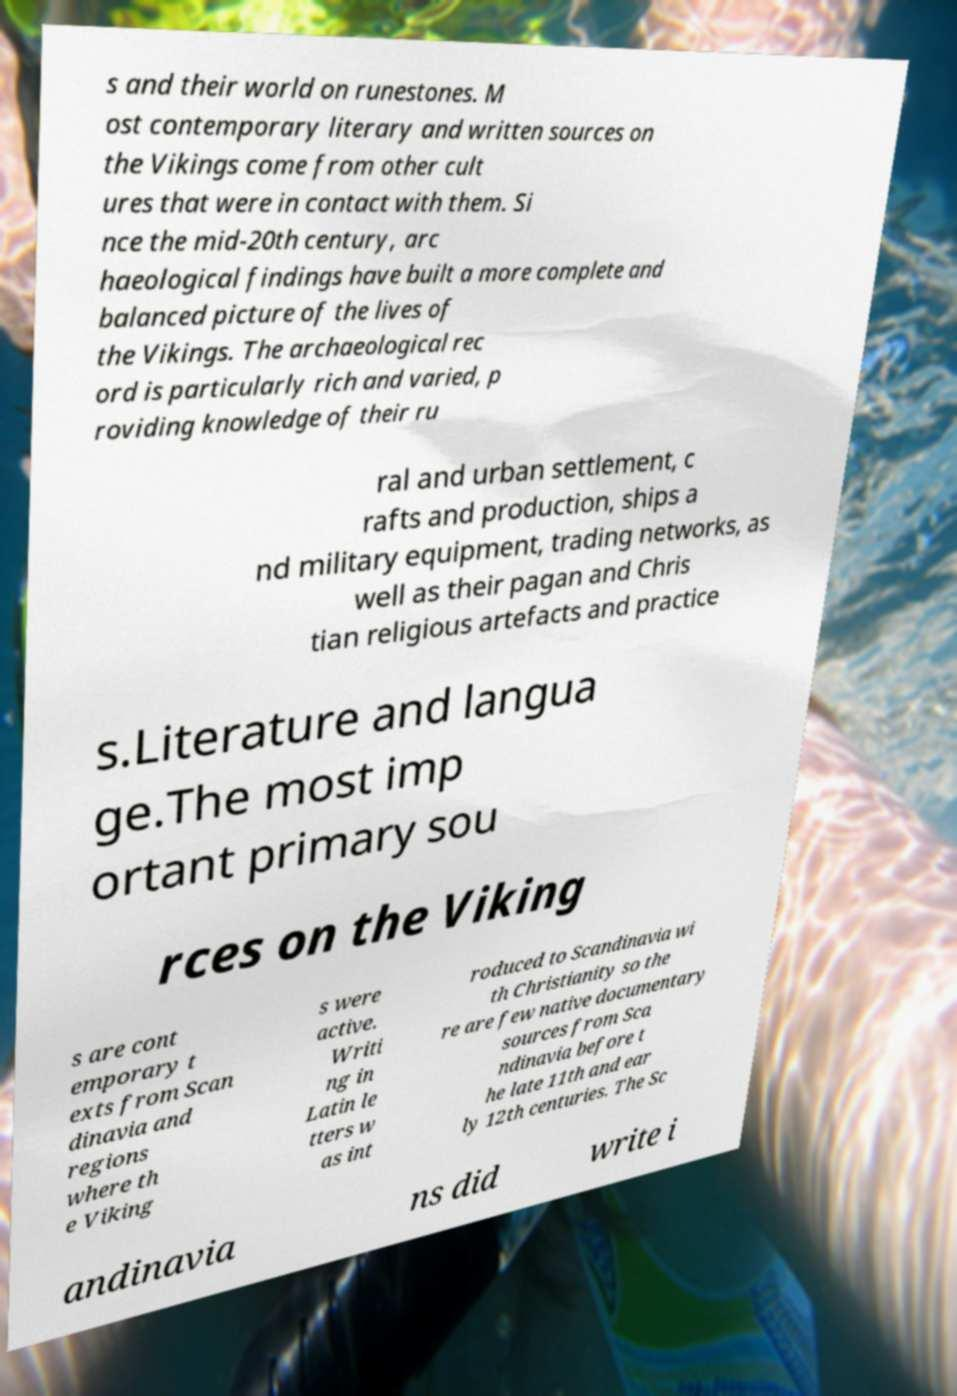Please read and relay the text visible in this image. What does it say? s and their world on runestones. M ost contemporary literary and written sources on the Vikings come from other cult ures that were in contact with them. Si nce the mid-20th century, arc haeological findings have built a more complete and balanced picture of the lives of the Vikings. The archaeological rec ord is particularly rich and varied, p roviding knowledge of their ru ral and urban settlement, c rafts and production, ships a nd military equipment, trading networks, as well as their pagan and Chris tian religious artefacts and practice s.Literature and langua ge.The most imp ortant primary sou rces on the Viking s are cont emporary t exts from Scan dinavia and regions where th e Viking s were active. Writi ng in Latin le tters w as int roduced to Scandinavia wi th Christianity so the re are few native documentary sources from Sca ndinavia before t he late 11th and ear ly 12th centuries. The Sc andinavia ns did write i 